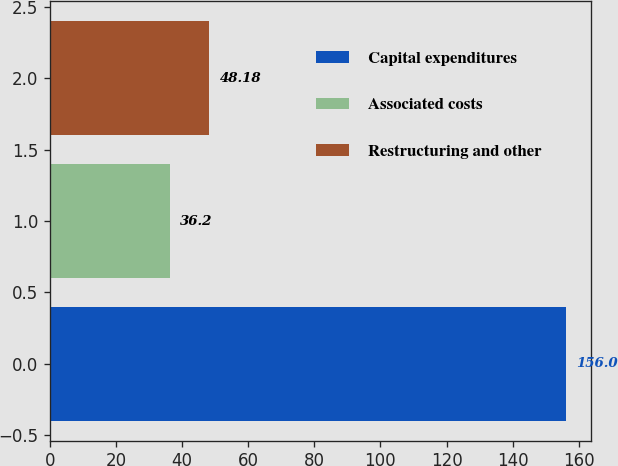<chart> <loc_0><loc_0><loc_500><loc_500><bar_chart><fcel>Capital expenditures<fcel>Associated costs<fcel>Restructuring and other<nl><fcel>156<fcel>36.2<fcel>48.18<nl></chart> 